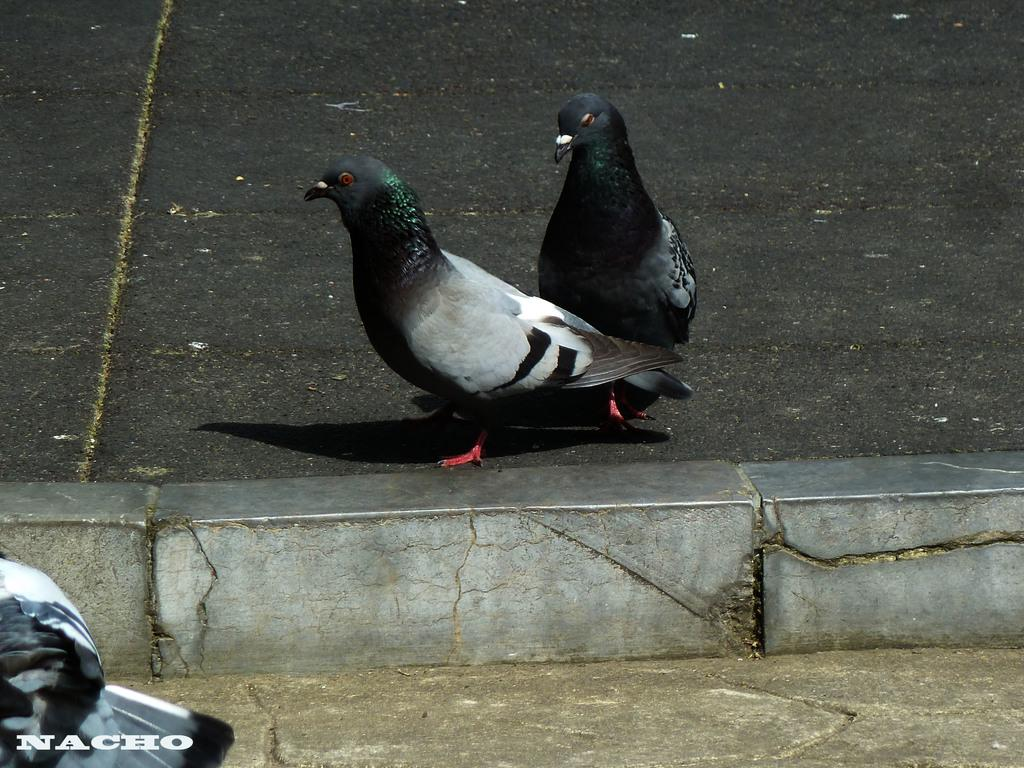What animals are in the middle of the image? There are two birds in the middle of the image. Where are the birds located? The birds are on the road. Are there any other birds visible in the image? Yes, there is another bird in the left corner of the image. What type of parcel is being delivered by the birds in the image? There is no parcel present in the image; it features birds on the road. Can you see a chessboard in the image? There is no chessboard present in the image. 